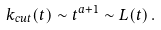Convert formula to latex. <formula><loc_0><loc_0><loc_500><loc_500>k _ { c u t } ( t ) \sim t ^ { a + 1 } \sim L ( t ) \, .</formula> 